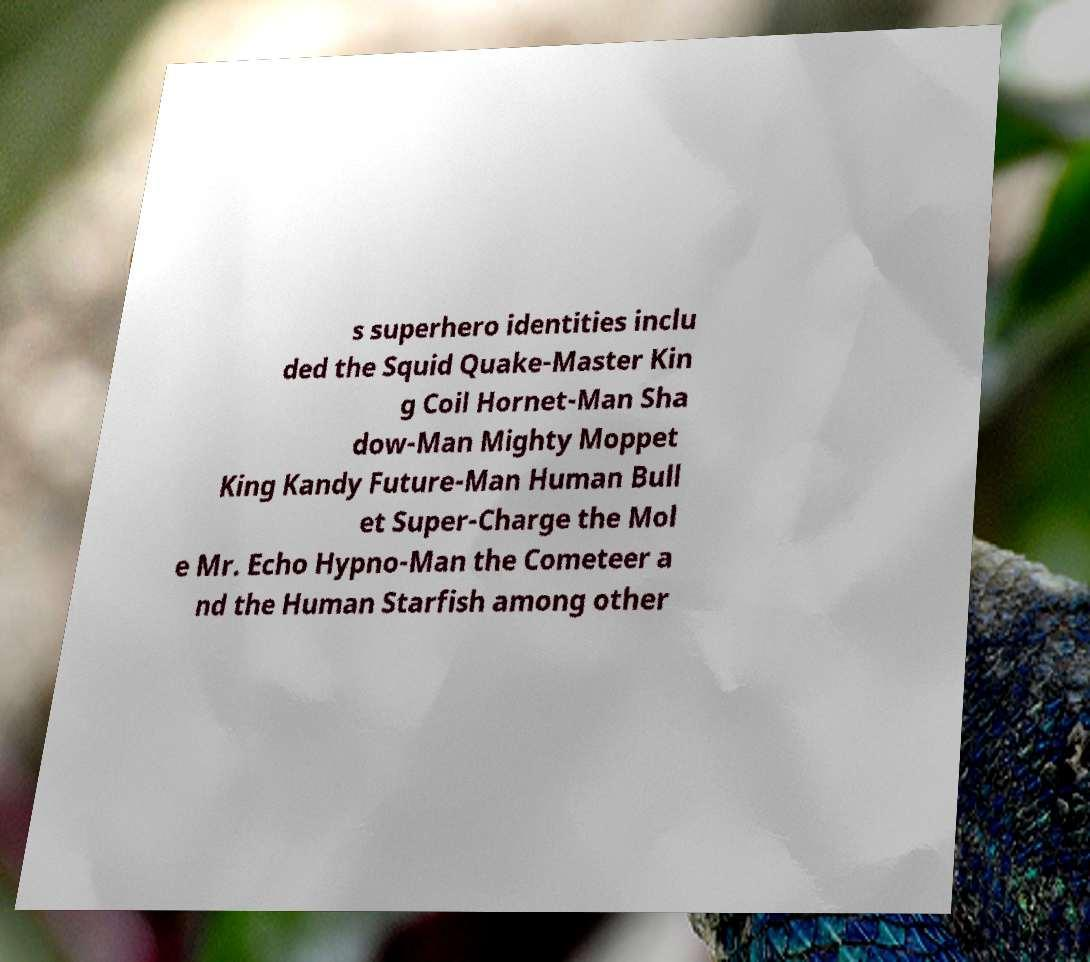Please identify and transcribe the text found in this image. s superhero identities inclu ded the Squid Quake-Master Kin g Coil Hornet-Man Sha dow-Man Mighty Moppet King Kandy Future-Man Human Bull et Super-Charge the Mol e Mr. Echo Hypno-Man the Cometeer a nd the Human Starfish among other 